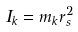Convert formula to latex. <formula><loc_0><loc_0><loc_500><loc_500>I _ { k } = m _ { k } r _ { s } ^ { 2 }</formula> 